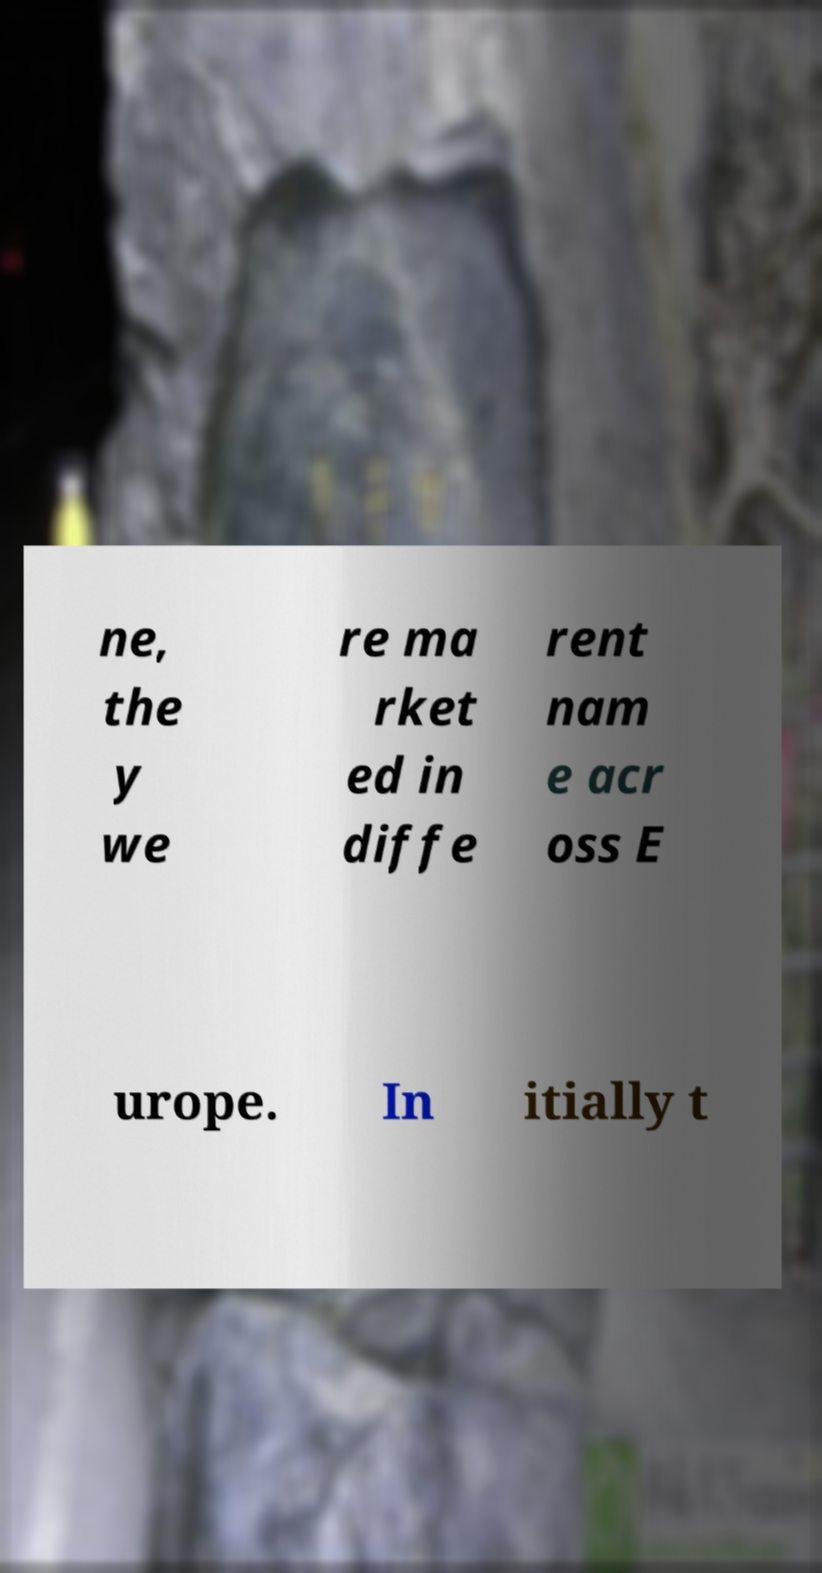Can you read and provide the text displayed in the image?This photo seems to have some interesting text. Can you extract and type it out for me? ne, the y we re ma rket ed in diffe rent nam e acr oss E urope. In itially t 